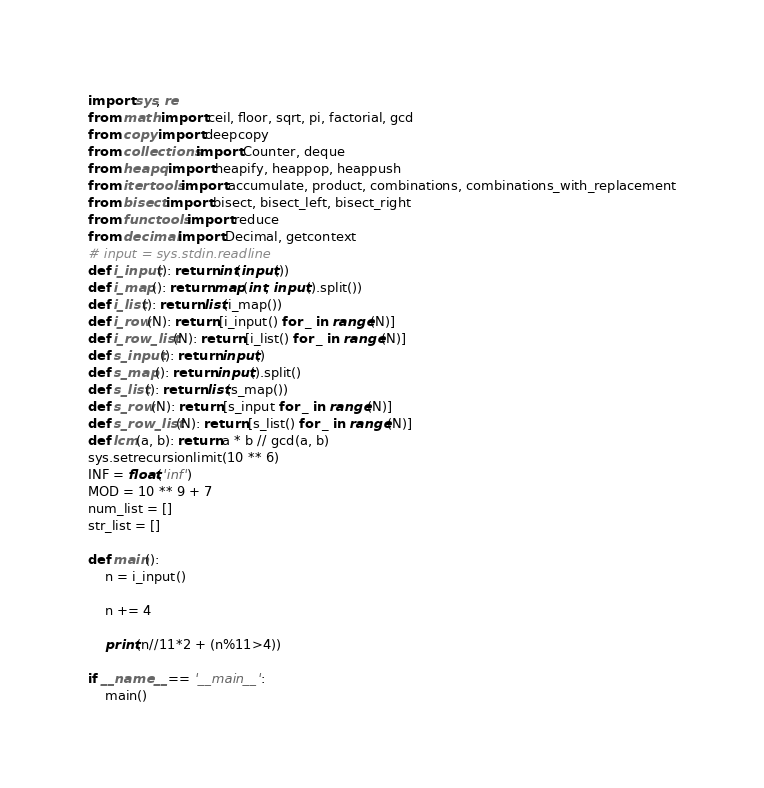Convert code to text. <code><loc_0><loc_0><loc_500><loc_500><_Python_>import sys, re
from math import ceil, floor, sqrt, pi, factorial, gcd
from copy import deepcopy
from collections import Counter, deque
from heapq import heapify, heappop, heappush
from itertools import accumulate, product, combinations, combinations_with_replacement
from bisect import bisect, bisect_left, bisect_right
from functools import reduce
from decimal import Decimal, getcontext
# input = sys.stdin.readline 
def i_input(): return int(input())
def i_map(): return map(int, input().split())
def i_list(): return list(i_map())
def i_row(N): return [i_input() for _ in range(N)]
def i_row_list(N): return [i_list() for _ in range(N)]
def s_input(): return input()
def s_map(): return input().split()
def s_list(): return list(s_map())
def s_row(N): return [s_input for _ in range(N)]
def s_row_list(N): return [s_list() for _ in range(N)]
def lcm(a, b): return a * b // gcd(a, b)
sys.setrecursionlimit(10 ** 6)
INF = float('inf')
MOD = 10 ** 9 + 7
num_list = []
str_list = []

def main():
    n = i_input()

    n += 4

    print(n//11*2 + (n%11>4))
 
if __name__ == '__main__':
    main()
</code> 